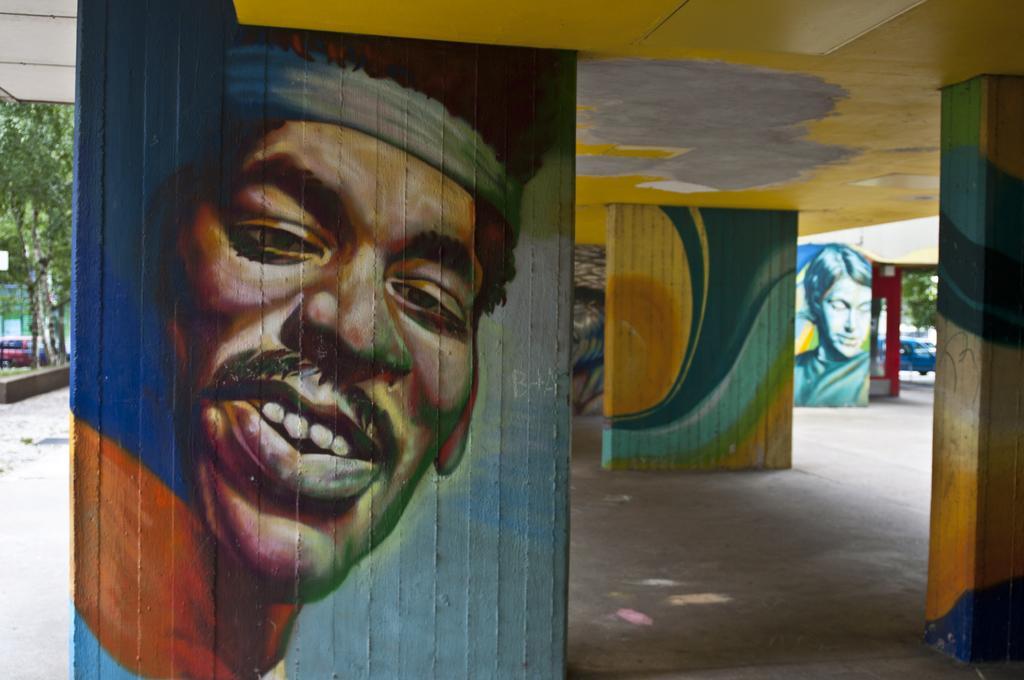Describe this image in one or two sentences. In this image it looks like a part of the building and there is a wall which is painted. And at the side there is a grass and trees. And there are cars on the road. 